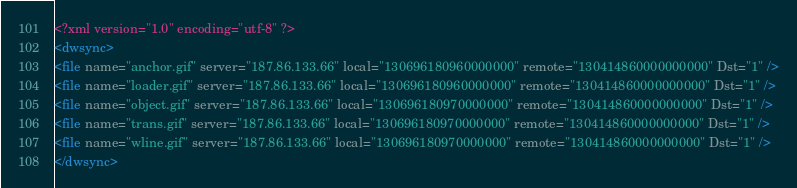<code> <loc_0><loc_0><loc_500><loc_500><_XML_><?xml version="1.0" encoding="utf-8" ?>
<dwsync>
<file name="anchor.gif" server="187.86.133.66" local="130696180960000000" remote="130414860000000000" Dst="1" />
<file name="loader.gif" server="187.86.133.66" local="130696180960000000" remote="130414860000000000" Dst="1" />
<file name="object.gif" server="187.86.133.66" local="130696180970000000" remote="130414860000000000" Dst="1" />
<file name="trans.gif" server="187.86.133.66" local="130696180970000000" remote="130414860000000000" Dst="1" />
<file name="wline.gif" server="187.86.133.66" local="130696180970000000" remote="130414860000000000" Dst="1" />
</dwsync></code> 